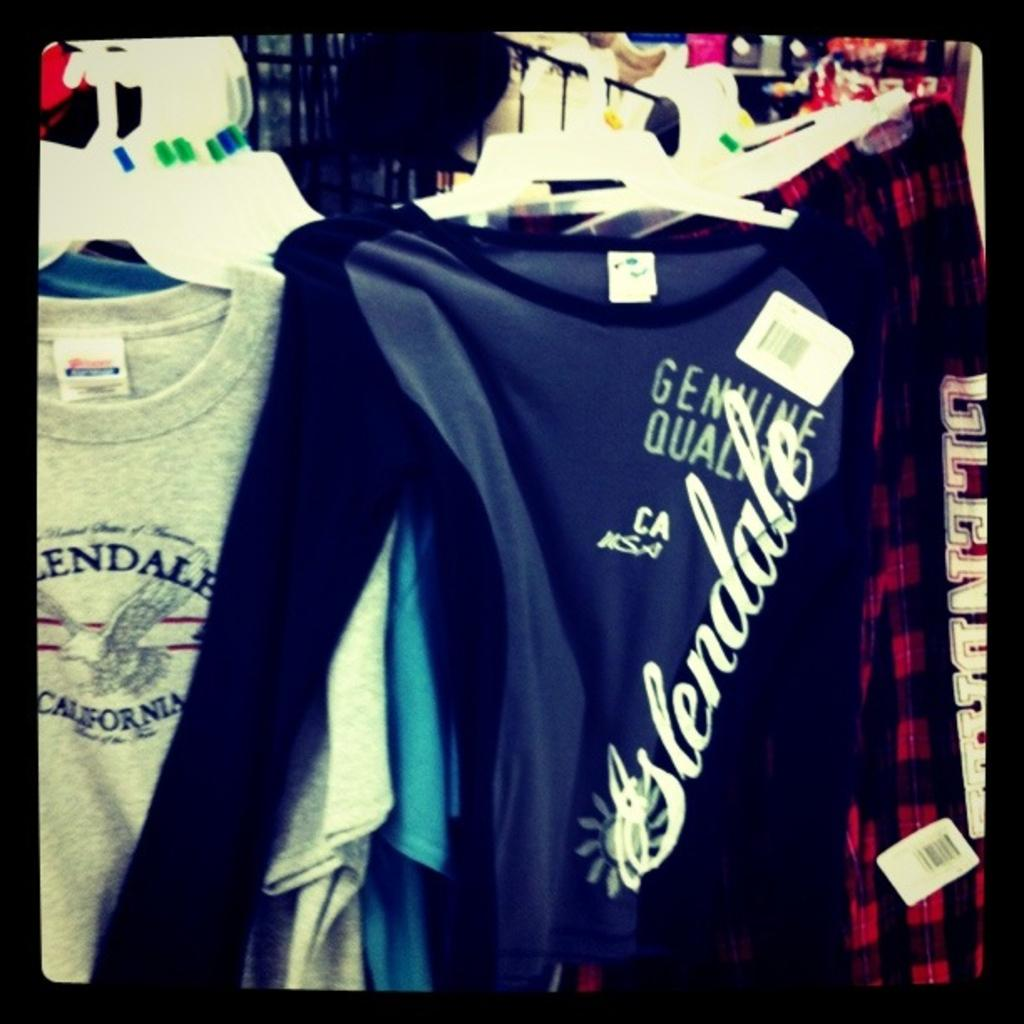<image>
Describe the image concisely. Glendale sells shirts featuring some genuine quality claims. 